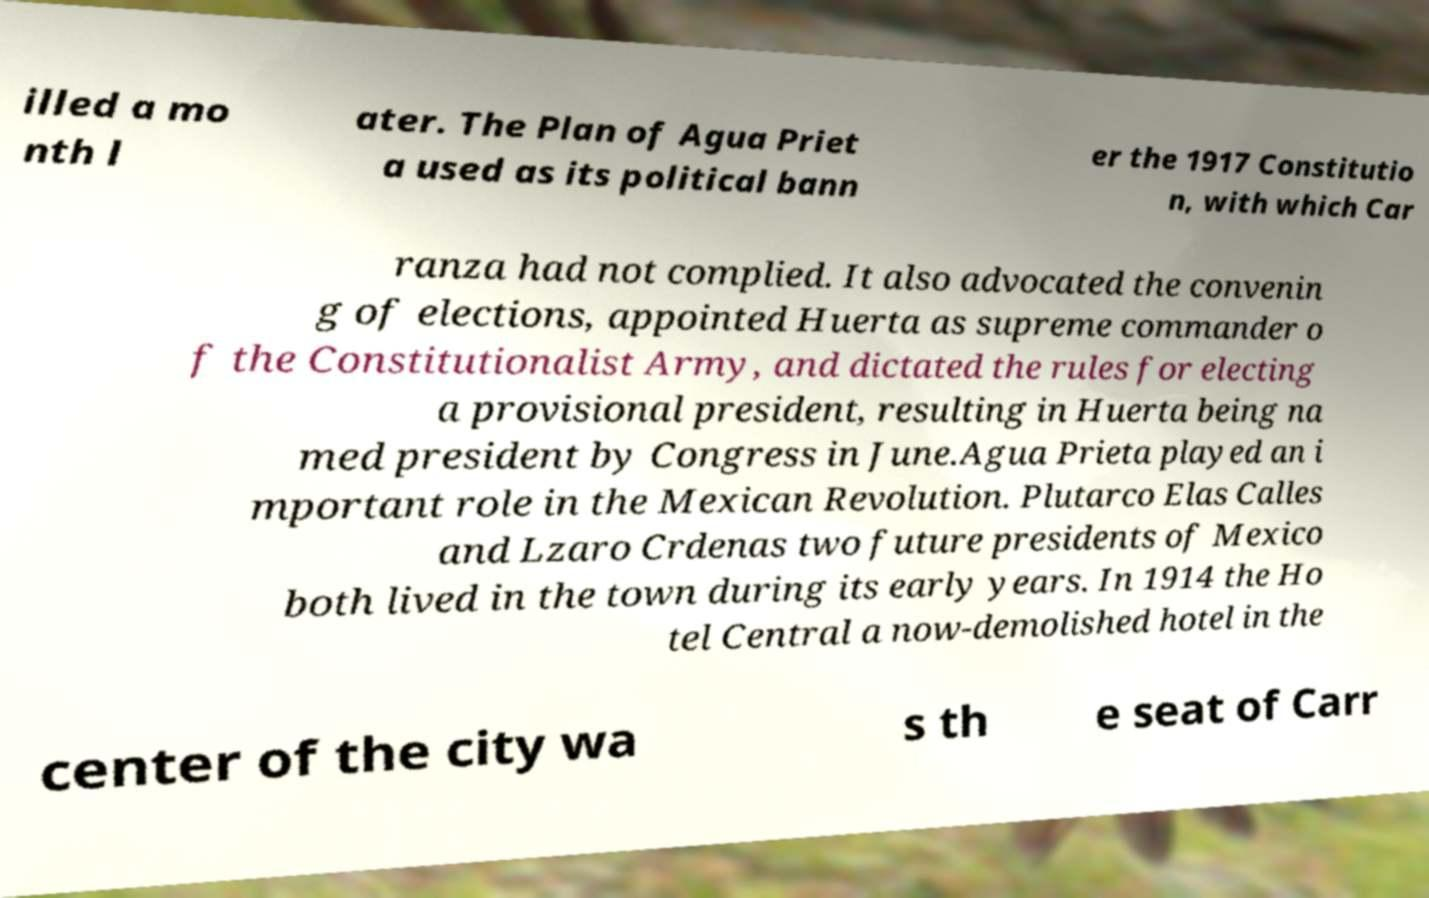Could you assist in decoding the text presented in this image and type it out clearly? illed a mo nth l ater. The Plan of Agua Priet a used as its political bann er the 1917 Constitutio n, with which Car ranza had not complied. It also advocated the convenin g of elections, appointed Huerta as supreme commander o f the Constitutionalist Army, and dictated the rules for electing a provisional president, resulting in Huerta being na med president by Congress in June.Agua Prieta played an i mportant role in the Mexican Revolution. Plutarco Elas Calles and Lzaro Crdenas two future presidents of Mexico both lived in the town during its early years. In 1914 the Ho tel Central a now-demolished hotel in the center of the city wa s th e seat of Carr 